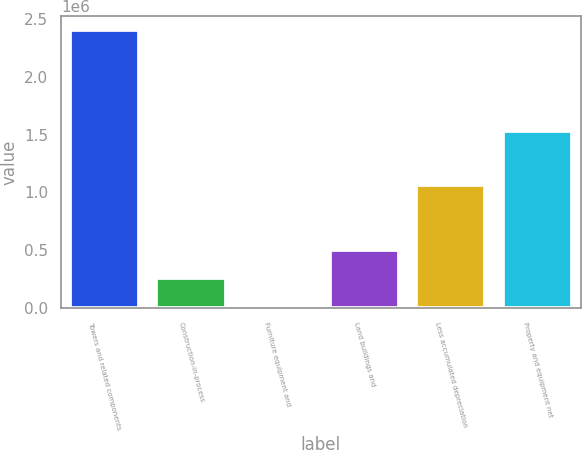Convert chart. <chart><loc_0><loc_0><loc_500><loc_500><bar_chart><fcel>Towers and related components<fcel>Construction-in-process<fcel>Furniture equipment and<fcel>Land buildings and<fcel>Less accumulated depreciation<fcel>Property and equipment net<nl><fcel>2.40732e+06<fcel>262373<fcel>24045<fcel>500700<fcel>1.06548e+06<fcel>1.53432e+06<nl></chart> 